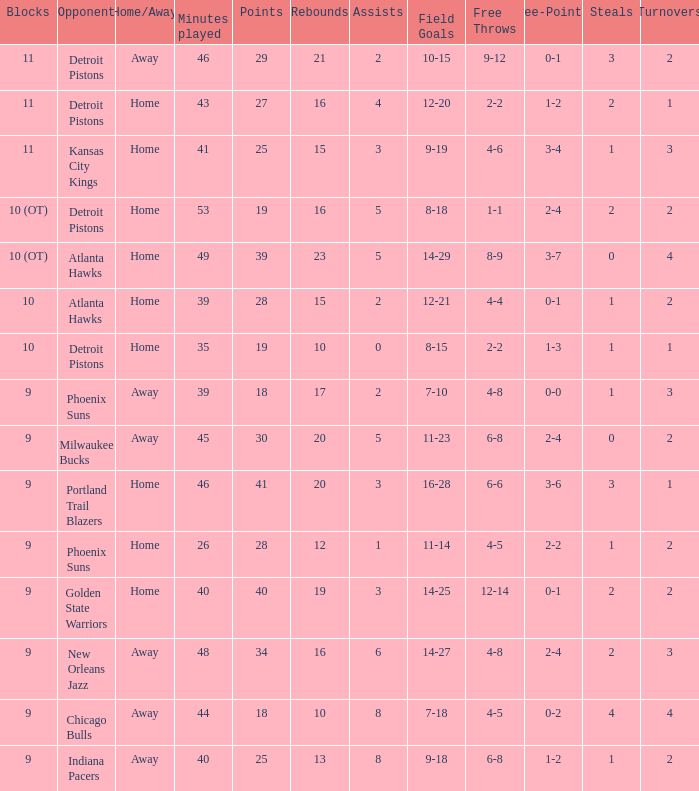How many minutes were played when there were 18 points and the opponent was Chicago Bulls? 1.0. 